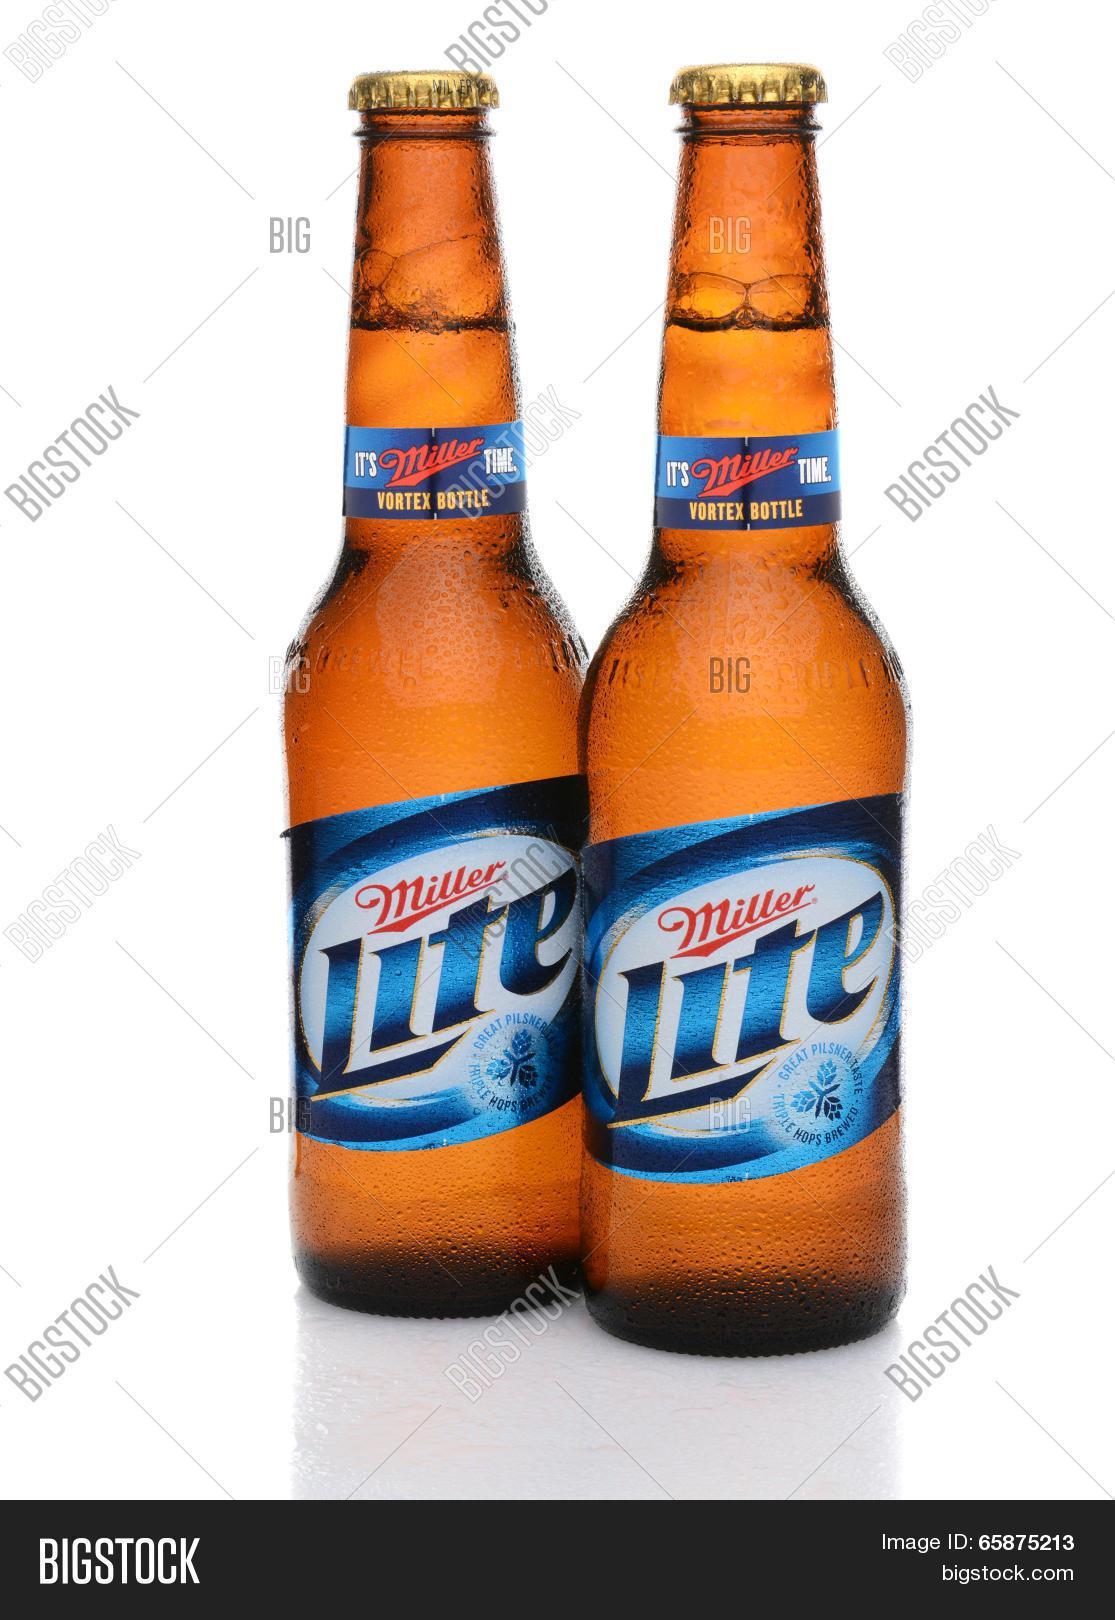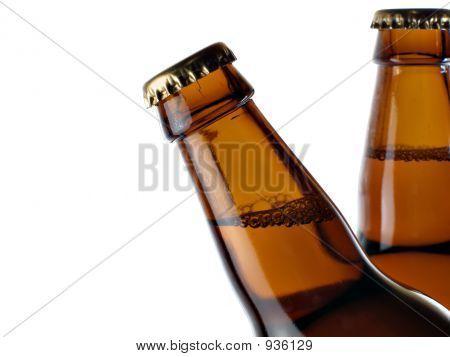The first image is the image on the left, the second image is the image on the right. For the images displayed, is the sentence "Bottles are protruding from a pile of ice." factually correct? Answer yes or no. No. The first image is the image on the left, the second image is the image on the right. For the images shown, is this caption "In one image, at least two beer bottles are capped and ice, but do not have a label." true? Answer yes or no. No. 